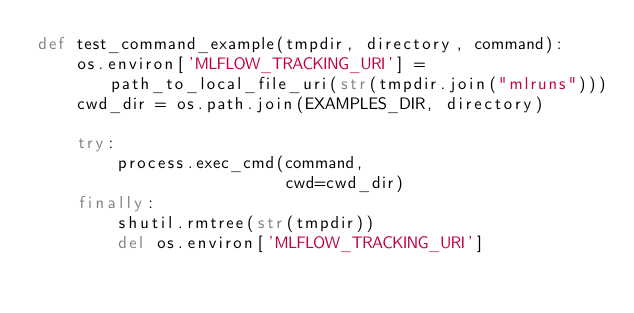<code> <loc_0><loc_0><loc_500><loc_500><_Python_>def test_command_example(tmpdir, directory, command):
    os.environ['MLFLOW_TRACKING_URI'] = path_to_local_file_uri(str(tmpdir.join("mlruns")))
    cwd_dir = os.path.join(EXAMPLES_DIR, directory)

    try:
        process.exec_cmd(command,
                         cwd=cwd_dir)
    finally:
        shutil.rmtree(str(tmpdir))
        del os.environ['MLFLOW_TRACKING_URI']
</code> 